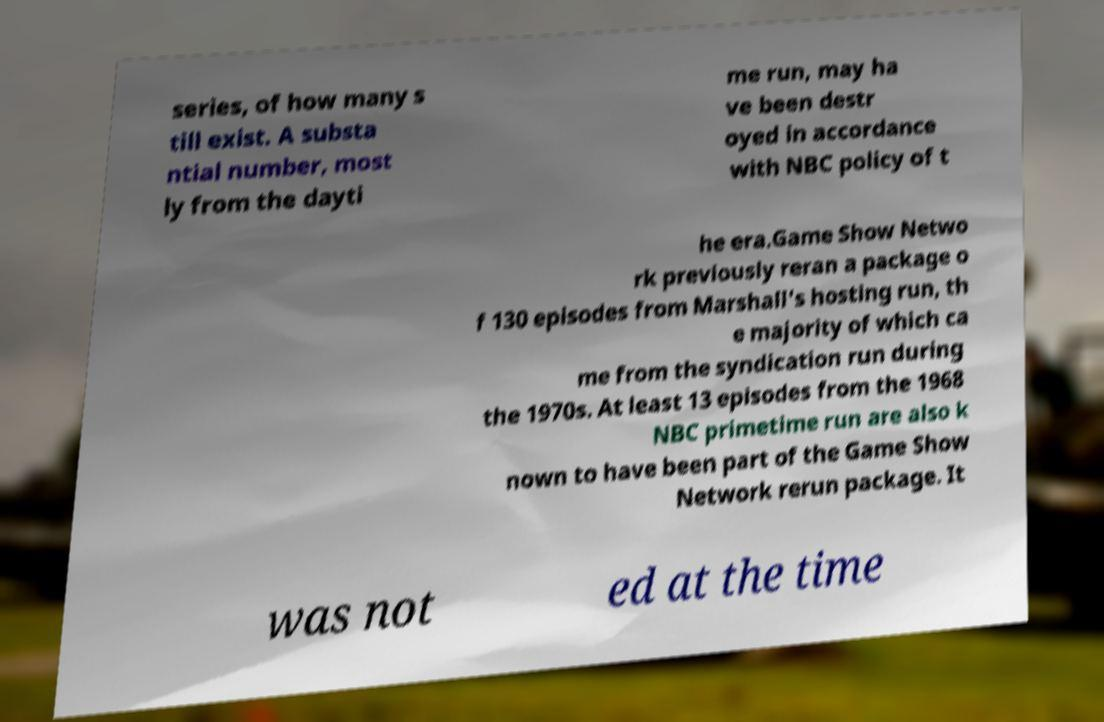Could you assist in decoding the text presented in this image and type it out clearly? series, of how many s till exist. A substa ntial number, most ly from the dayti me run, may ha ve been destr oyed in accordance with NBC policy of t he era.Game Show Netwo rk previously reran a package o f 130 episodes from Marshall's hosting run, th e majority of which ca me from the syndication run during the 1970s. At least 13 episodes from the 1968 NBC primetime run are also k nown to have been part of the Game Show Network rerun package. It was not ed at the time 